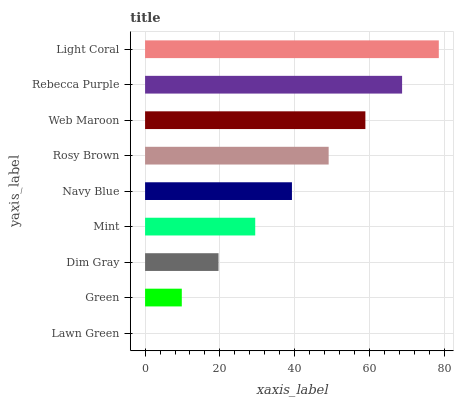Is Lawn Green the minimum?
Answer yes or no. Yes. Is Light Coral the maximum?
Answer yes or no. Yes. Is Green the minimum?
Answer yes or no. No. Is Green the maximum?
Answer yes or no. No. Is Green greater than Lawn Green?
Answer yes or no. Yes. Is Lawn Green less than Green?
Answer yes or no. Yes. Is Lawn Green greater than Green?
Answer yes or no. No. Is Green less than Lawn Green?
Answer yes or no. No. Is Navy Blue the high median?
Answer yes or no. Yes. Is Navy Blue the low median?
Answer yes or no. Yes. Is Web Maroon the high median?
Answer yes or no. No. Is Green the low median?
Answer yes or no. No. 